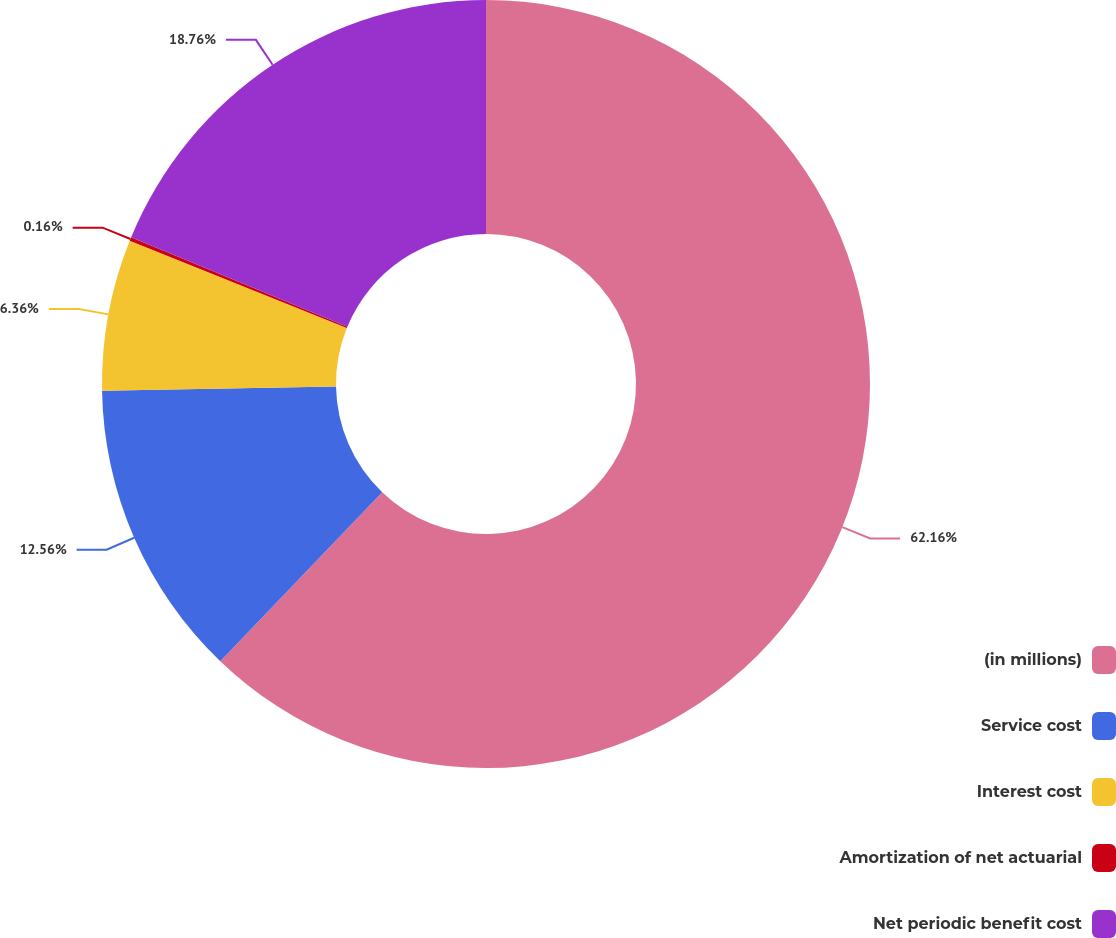Convert chart to OTSL. <chart><loc_0><loc_0><loc_500><loc_500><pie_chart><fcel>(in millions)<fcel>Service cost<fcel>Interest cost<fcel>Amortization of net actuarial<fcel>Net periodic benefit cost<nl><fcel>62.17%<fcel>12.56%<fcel>6.36%<fcel>0.16%<fcel>18.76%<nl></chart> 